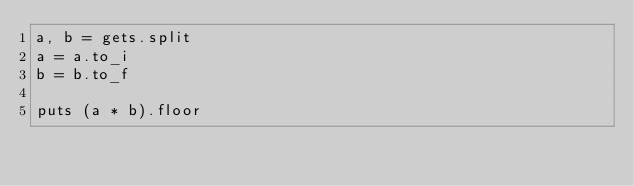<code> <loc_0><loc_0><loc_500><loc_500><_Ruby_>a, b = gets.split
a = a.to_i
b = b.to_f

puts (a * b).floor
</code> 